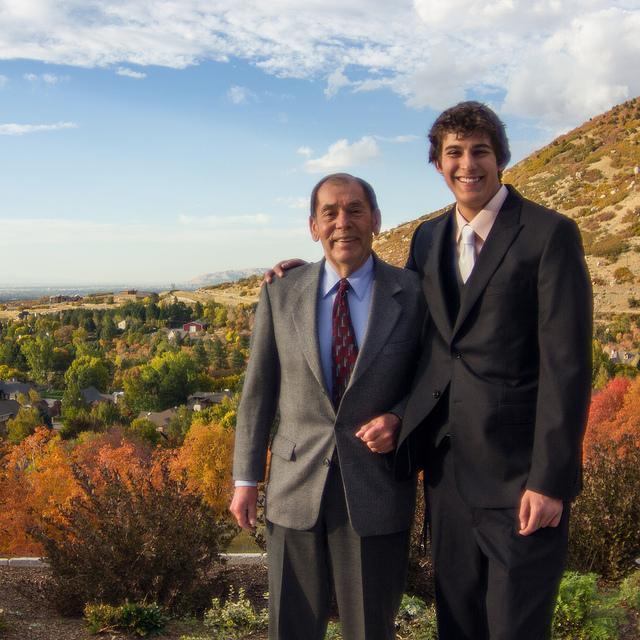What type setting do these men pose in?
Pick the right solution, then justify: 'Answer: answer
Rationale: rationale.'
Options: Circus, suburban, city, farm. Answer: farm.
Rationale: The setting is a farm. 